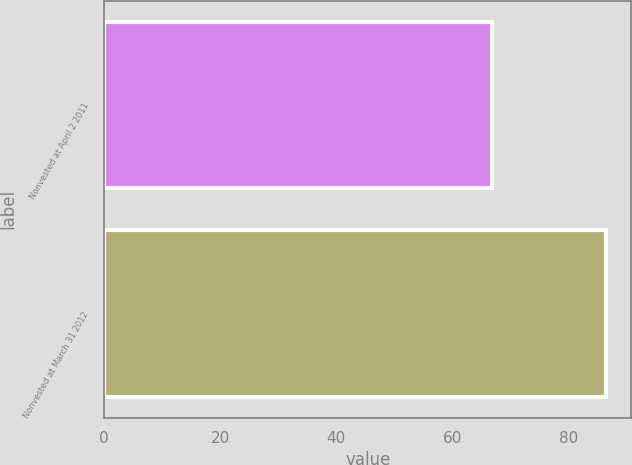Convert chart to OTSL. <chart><loc_0><loc_0><loc_500><loc_500><bar_chart><fcel>Nonvested at April 2 2011<fcel>Nonvested at March 31 2012<nl><fcel>66.78<fcel>86.53<nl></chart> 